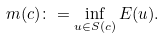<formula> <loc_0><loc_0><loc_500><loc_500>m ( c ) \colon = \inf _ { u \in S ( c ) } E ( u ) .</formula> 